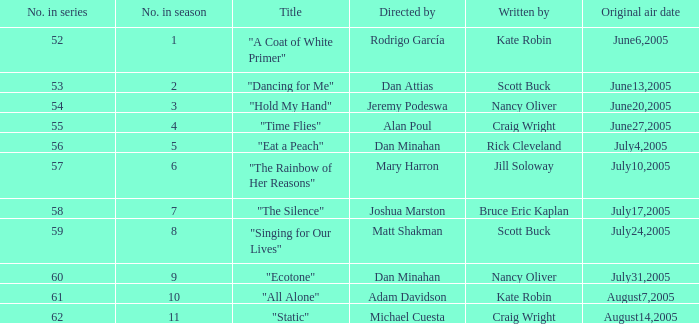Write the full table. {'header': ['No. in series', 'No. in season', 'Title', 'Directed by', 'Written by', 'Original air date'], 'rows': [['52', '1', '"A Coat of White Primer"', 'Rodrigo García', 'Kate Robin', 'June6,2005'], ['53', '2', '"Dancing for Me"', 'Dan Attias', 'Scott Buck', 'June13,2005'], ['54', '3', '"Hold My Hand"', 'Jeremy Podeswa', 'Nancy Oliver', 'June20,2005'], ['55', '4', '"Time Flies"', 'Alan Poul', 'Craig Wright', 'June27,2005'], ['56', '5', '"Eat a Peach"', 'Dan Minahan', 'Rick Cleveland', 'July4,2005'], ['57', '6', '"The Rainbow of Her Reasons"', 'Mary Harron', 'Jill Soloway', 'July10,2005'], ['58', '7', '"The Silence"', 'Joshua Marston', 'Bruce Eric Kaplan', 'July17,2005'], ['59', '8', '"Singing for Our Lives"', 'Matt Shakman', 'Scott Buck', 'July24,2005'], ['60', '9', '"Ecotone"', 'Dan Minahan', 'Nancy Oliver', 'July31,2005'], ['61', '10', '"All Alone"', 'Adam Davidson', 'Kate Robin', 'August7,2005'], ['62', '11', '"Static"', 'Michael Cuesta', 'Craig Wright', 'August14,2005']]} What date was episode 10 in the season originally aired? August7,2005. 